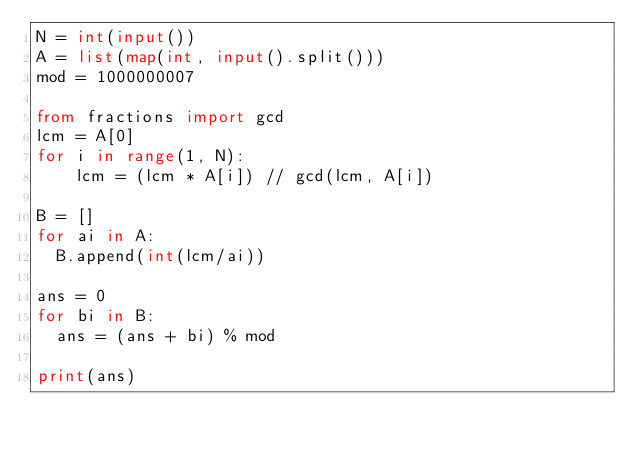Convert code to text. <code><loc_0><loc_0><loc_500><loc_500><_Python_>N = int(input())
A = list(map(int, input().split()))
mod = 1000000007

from fractions import gcd
lcm = A[0]
for i in range(1, N):
    lcm = (lcm * A[i]) // gcd(lcm, A[i])

B = []
for ai in A:
  B.append(int(lcm/ai))

ans = 0
for bi in B:
  ans = (ans + bi) % mod

print(ans)</code> 